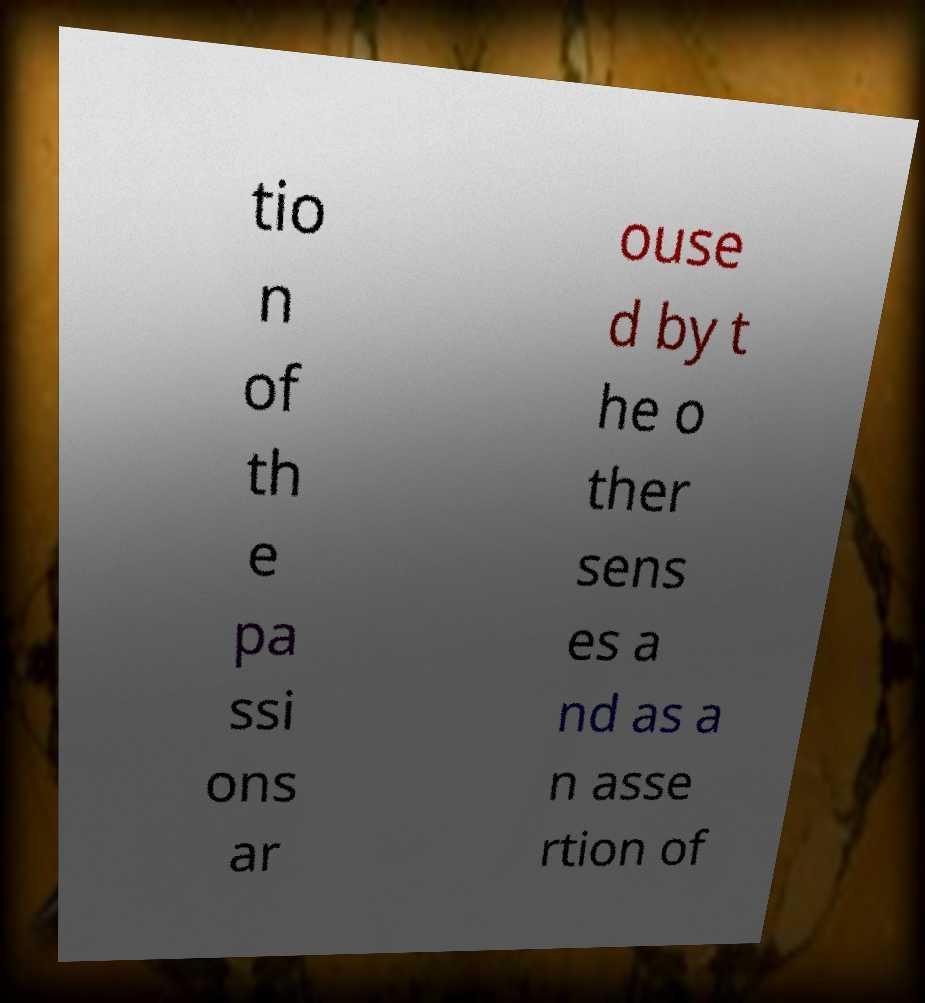For documentation purposes, I need the text within this image transcribed. Could you provide that? tio n of th e pa ssi ons ar ouse d by t he o ther sens es a nd as a n asse rtion of 